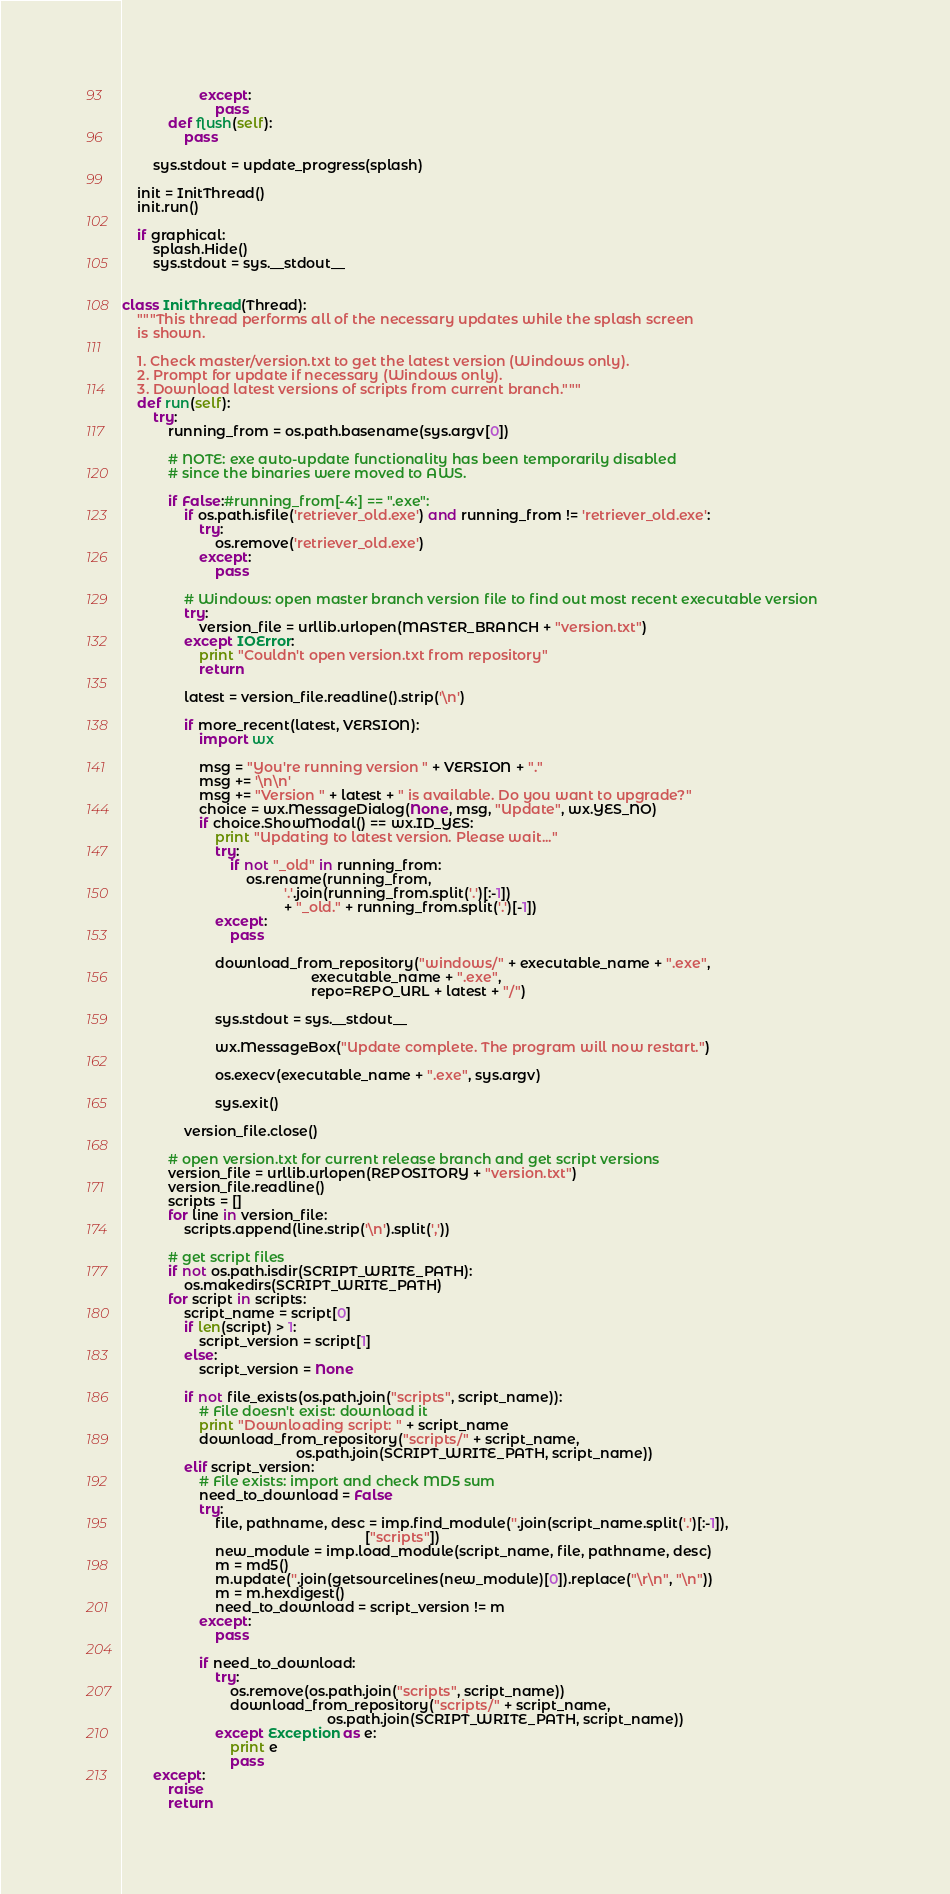<code> <loc_0><loc_0><loc_500><loc_500><_Python_>                    except:
                        pass
            def flush(self):
                pass
                
        sys.stdout = update_progress(splash)
    
    init = InitThread()
    init.run()
    
    if graphical:
        splash.Hide()
        sys.stdout = sys.__stdout__
    
    
class InitThread(Thread):
    """This thread performs all of the necessary updates while the splash screen
    is shown.

    1. Check master/version.txt to get the latest version (Windows only).
    2. Prompt for update if necessary (Windows only).
    3. Download latest versions of scripts from current branch."""
    def run(self):
        try:
            running_from = os.path.basename(sys.argv[0])
            
            # NOTE: exe auto-update functionality has been temporarily disabled 
            # since the binaries were moved to AWS.

            if False:#running_from[-4:] == ".exe":
                if os.path.isfile('retriever_old.exe') and running_from != 'retriever_old.exe':
                    try:
                        os.remove('retriever_old.exe')
                    except:
                        pass

                # Windows: open master branch version file to find out most recent executable version            
                try:
                    version_file = urllib.urlopen(MASTER_BRANCH + "version.txt")
                except IOError:
                    print "Couldn't open version.txt from repository"
                    return
                    
                latest = version_file.readline().strip('\n')
                    
                if more_recent(latest, VERSION):
                    import wx

                    msg = "You're running version " + VERSION + "."
                    msg += '\n\n'
                    msg += "Version " + latest + " is available. Do you want to upgrade?"
                    choice = wx.MessageDialog(None, msg, "Update", wx.YES_NO)
                    if choice.ShowModal() == wx.ID_YES:
                        print "Updating to latest version. Please wait..."
                        try:
                            if not "_old" in running_from:
                                os.rename(running_from,
                                          '.'.join(running_from.split('.')[:-1])
                                          + "_old." + running_from.split('.')[-1])
                        except:
                            pass
                                
                        download_from_repository("windows/" + executable_name + ".exe",
                                                 executable_name + ".exe",
                                                 repo=REPO_URL + latest + "/")

                        sys.stdout = sys.__stdout__

                        wx.MessageBox("Update complete. The program will now restart.")

                        os.execv(executable_name + ".exe", sys.argv)
                            
                        sys.exit()

                version_file.close()

            # open version.txt for current release branch and get script versions
            version_file = urllib.urlopen(REPOSITORY + "version.txt")
            version_file.readline()
            scripts = []
            for line in version_file:
                scripts.append(line.strip('\n').split(','))
            
            # get script files
            if not os.path.isdir(SCRIPT_WRITE_PATH):
                os.makedirs(SCRIPT_WRITE_PATH)
            for script in scripts:
                script_name = script[0]
                if len(script) > 1:
                    script_version = script[1]
                else:
                    script_version = None

                if not file_exists(os.path.join("scripts", script_name)):
                    # File doesn't exist: download it
                    print "Downloading script: " + script_name
                    download_from_repository("scripts/" + script_name,
                                             os.path.join(SCRIPT_WRITE_PATH, script_name))
                elif script_version:
                    # File exists: import and check MD5 sum
                    need_to_download = False
                    try:
                        file, pathname, desc = imp.find_module(''.join(script_name.split('.')[:-1]), 
                                                               ["scripts"])
                        new_module = imp.load_module(script_name, file, pathname, desc)
                        m = md5()
                        m.update(''.join(getsourcelines(new_module)[0]).replace("\r\n", "\n"))
                        m = m.hexdigest()
                        need_to_download = script_version != m
                    except:            
                        pass
                                
                    if need_to_download:
                        try:
                            os.remove(os.path.join("scripts", script_name))
                            download_from_repository("scripts/" + script_name,
                                                     os.path.join(SCRIPT_WRITE_PATH, script_name))
                        except Exception as e:
                            print e
                            pass
        except:
            raise
            return
</code> 